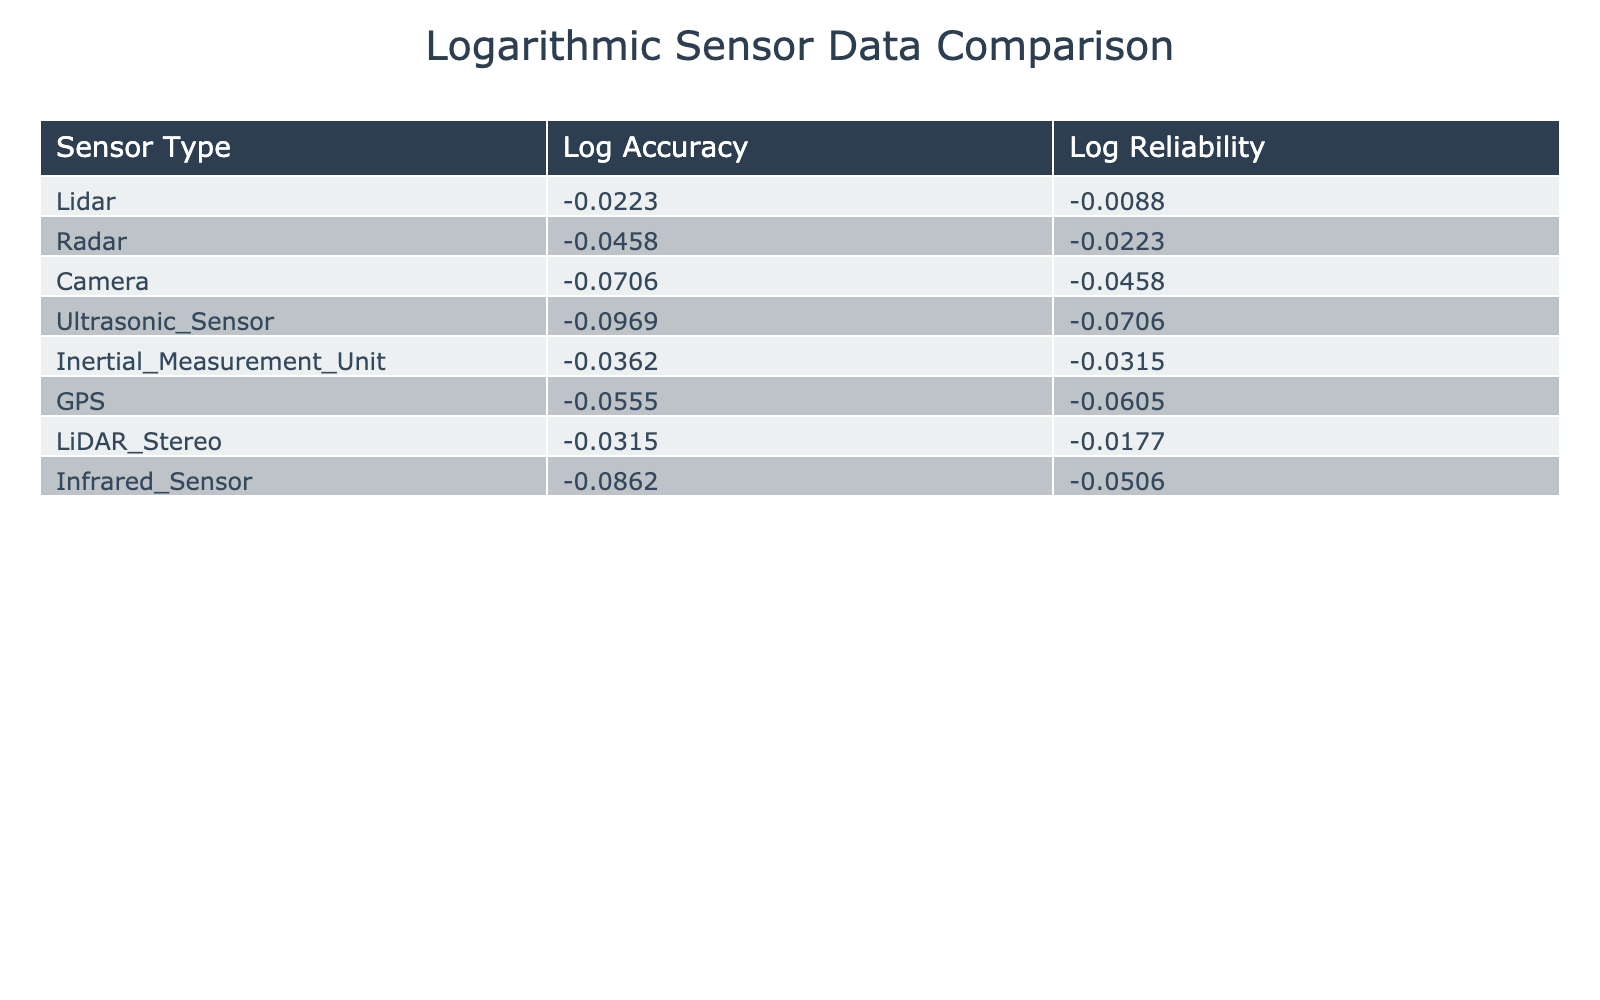What is the logarithmic accuracy of the Camera sensor? The table shows the Log Accuracy associated with the Camera sensor under the 'Log Accuracy' column, which is listed as 0.9294.
Answer: 0.9294 Which sensor has the highest reliability score? By examining the Reliability Score column, the Lidar sensor has the highest score of 0.98.
Answer: Lidar What is the difference between the logarithmic accuracy of the LiDAR Stereo and the Ultrasonic Sensor? The Log Accuracy for LiDAR Stereo is 0.9691 and for Ultrasonic Sensor, it is 0.9031. The difference can be calculated as 0.9691 - 0.9031 = 0.0660.
Answer: 0.0660 Is the reliability score of the GPS sensor greater than 0.90? Looking at the Reliability Score for the GPS sensor, it is listed as 0.87 which is less than 0.90.
Answer: No What is the average logarithmic accuracy of all sensory devices listed? To calculate the average: (log(0.95) + log(0.90) + log(0.85) + log(0.80) + log(0.92) + log(0.88) + log(0.93) + log(0.82)) / 8 = (0.9788 + 0.9542 + 0.9294 + 0.9030 + 0.9677 + 0.9442 + 0.9691 + 0.9138) / 8 = 0.9541.
Answer: 0.9541 Which sensor has both high accuracy and high reliability? Evaluating the table, the Lidar sensor demonstrates both high accuracy (0.95) and high reliability (0.98), making it stand out.
Answer: Lidar What is the logarithmic reliability score of the Inertial Measurement Unit? The logarithmic reliability score for the Inertial Measurement Unit is shown as 0.9685 in the table under the Log Reliability column.
Answer: 0.9685 How do the reliability scores of the Camera and GPS compare? The reliability score for Camera is 0.90 and for GPS it is 0.87. Therefore, Camera has a higher score.
Answer: Camera has a higher reliability score If you combine the logarithmic accuracies of the Lidar and Inertial Measurement Unit, what do you get? The Log Accuracy for Lidar is 0.9788 and for Inertial Measurement Unit is 0.9677. Adding these together gives 0.9788 + 0.9677 = 1.9465.
Answer: 1.9465 